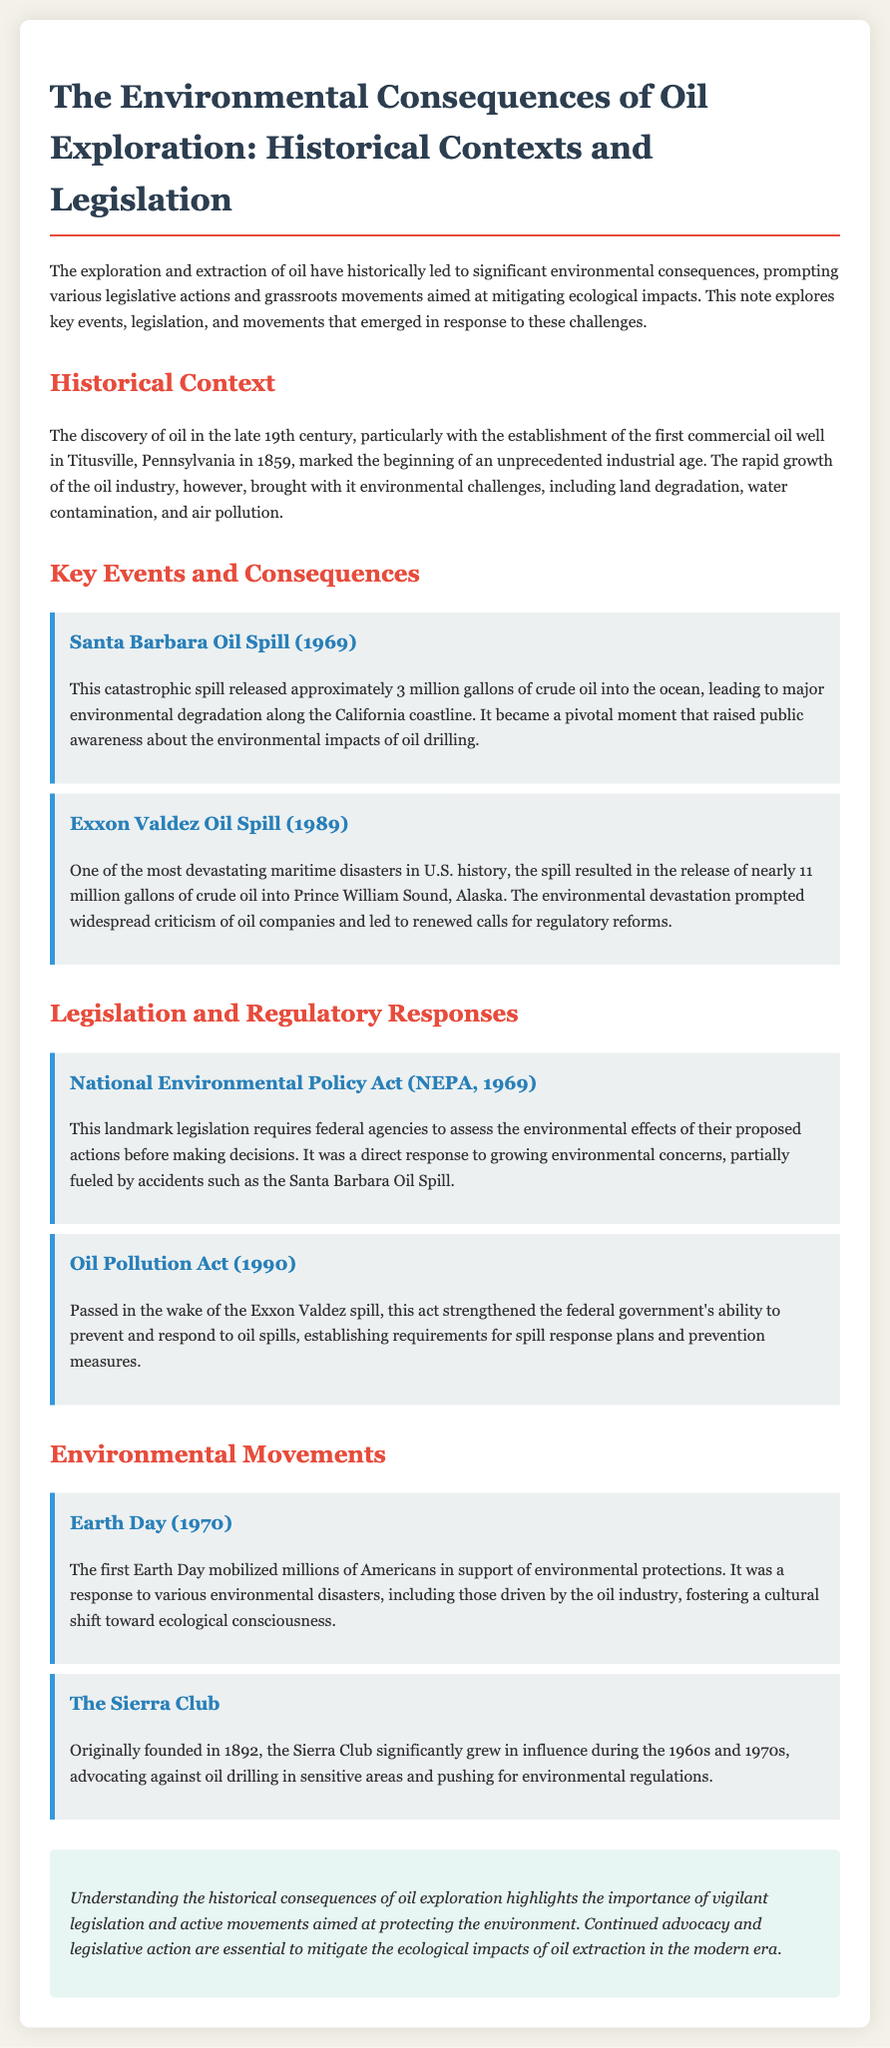What year was the first commercial oil well established? The first commercial oil well was established in 1859 in Titusville, Pennsylvania.
Answer: 1859 What was released during the Santa Barbara Oil Spill? The Santa Barbara Oil Spill released approximately 3 million gallons of crude oil into the ocean.
Answer: 3 million gallons Which legislation requires federal agencies to assess environmental effects? The National Environmental Policy Act requires federal agencies to assess environmental effects before making decisions.
Answer: National Environmental Policy Act What major environmental event occurred in 1989? The Exxon Valdez Oil Spill was a significant environmental event that occurred in 1989.
Answer: Exxon Valdez Oil Spill What grassroots movement mobilized in 1970 for environmental protections? The first Earth Day mobilized millions of Americans in support of environmental protections.
Answer: Earth Day What was a direct response to the Exxon Valdez spill? The Oil Pollution Act was passed in direct response to the Exxon Valdez spill.
Answer: Oil Pollution Act Which organization grew in influence during the 1960s and 1970s advocating against oil drilling? The Sierra Club significantly grew in influence during the 1960s and 1970s.
Answer: The Sierra Club What is the purpose of the Oil Pollution Act? The Oil Pollution Act strengthened the federal government's ability to prevent and respond to oil spills.
Answer: Prevent and respond to oil spills What was a consequence of the Santa Barbara Oil Spill? The Santa Barbara Oil Spill raised public awareness about the environmental impacts of oil drilling.
Answer: Public awareness 